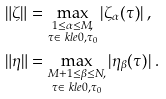Convert formula to latex. <formula><loc_0><loc_0><loc_500><loc_500>\| \zeta \| & = \max _ { \substack { 1 \leq \alpha \leq M , \\ \tau \in \ k l e { 0 , \tau _ { 0 } } } } | \zeta _ { \alpha } ( \tau ) | \ , \\ \| \eta \| & = \max _ { \substack { M + 1 \leq \beta \leq N , \\ \tau \in \ k l e { 0 , \tau _ { 0 } } } } | \eta _ { \beta } ( \tau ) | \ .</formula> 